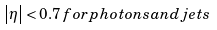Convert formula to latex. <formula><loc_0><loc_0><loc_500><loc_500>\left | \eta \right | < 0 . 7 \, f o r p h o t o n s a n d j e t s</formula> 